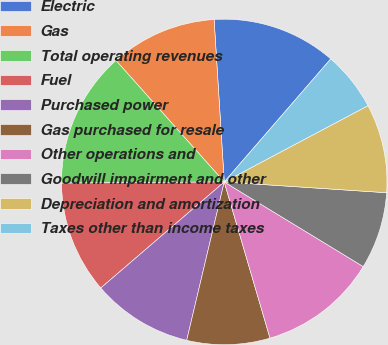Convert chart. <chart><loc_0><loc_0><loc_500><loc_500><pie_chart><fcel>Electric<fcel>Gas<fcel>Total operating revenues<fcel>Fuel<fcel>Purchased power<fcel>Gas purchased for resale<fcel>Other operations and<fcel>Goodwill impairment and other<fcel>Depreciation and amortization<fcel>Taxes other than income taxes<nl><fcel>12.35%<fcel>10.59%<fcel>13.53%<fcel>11.18%<fcel>10.0%<fcel>8.24%<fcel>11.76%<fcel>7.65%<fcel>8.82%<fcel>5.88%<nl></chart> 